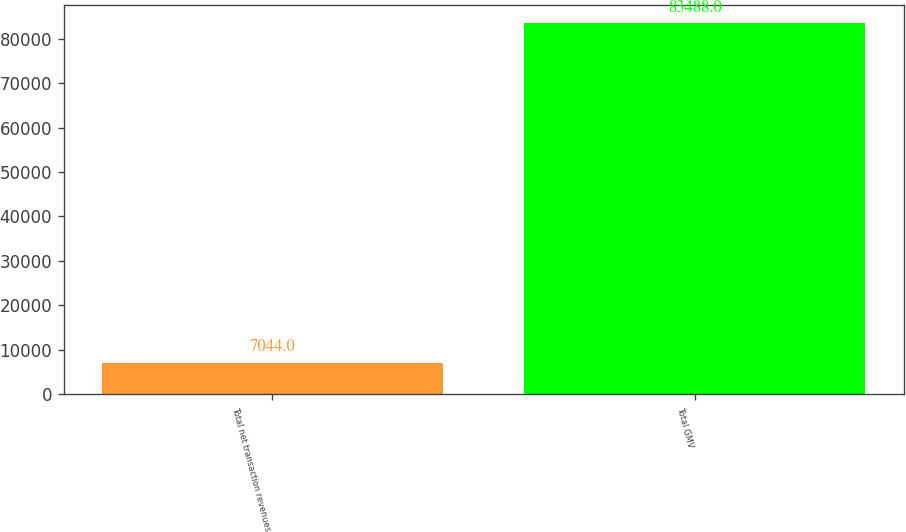Convert chart to OTSL. <chart><loc_0><loc_0><loc_500><loc_500><bar_chart><fcel>Total net transaction revenues<fcel>Total GMV<nl><fcel>7044<fcel>83488<nl></chart> 